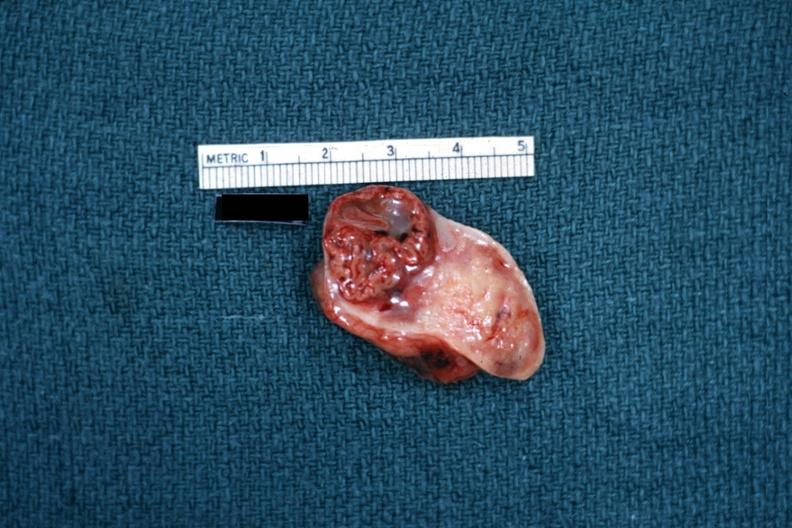what is present?
Answer the question using a single word or phrase. Ovary 